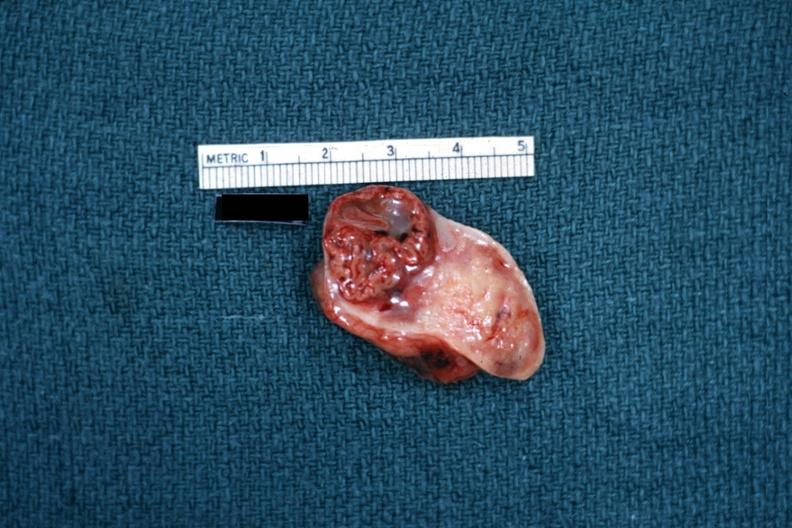what is present?
Answer the question using a single word or phrase. Ovary 